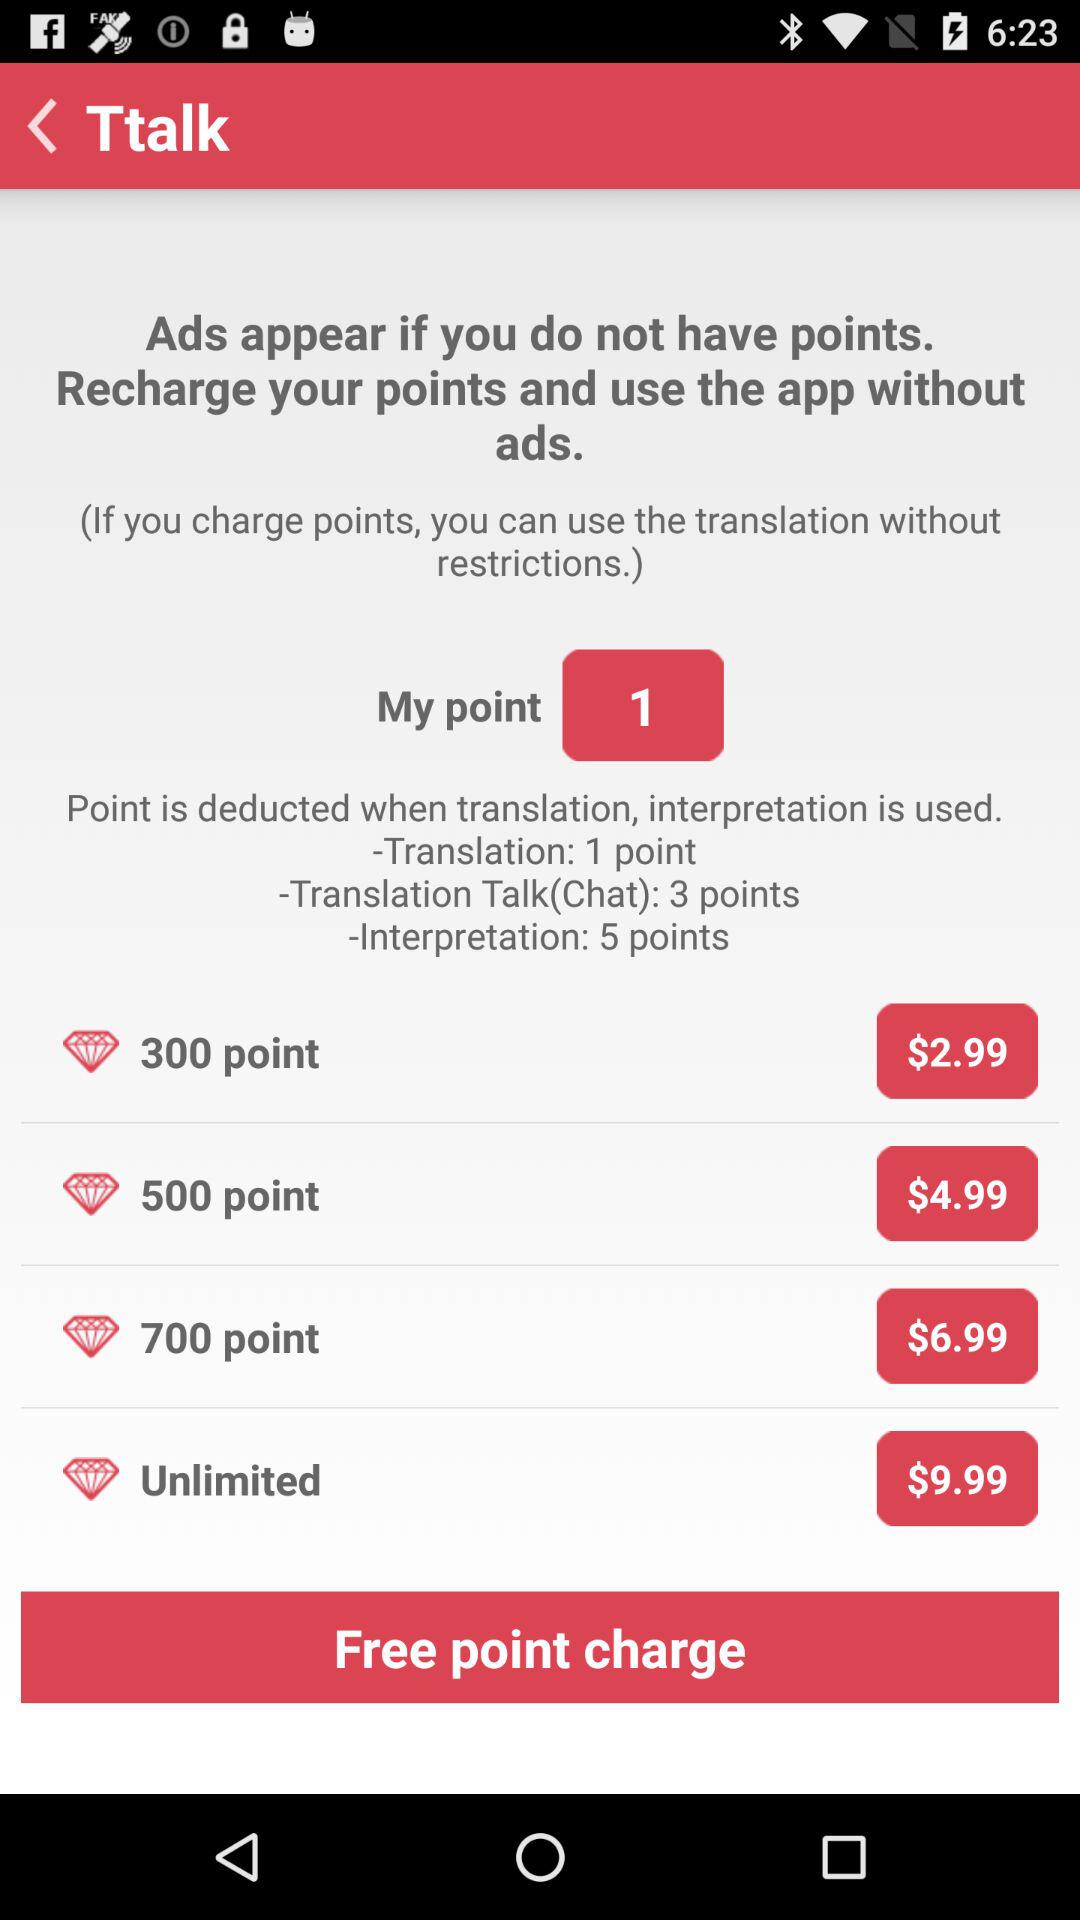What is the number of "My point"? The number of "My point" is 1. 